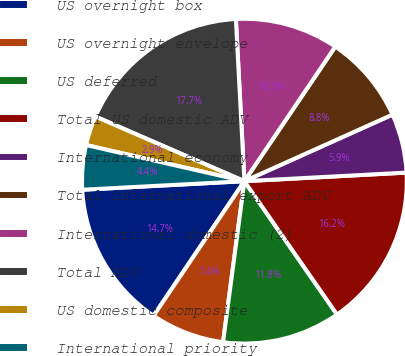<chart> <loc_0><loc_0><loc_500><loc_500><pie_chart><fcel>US overnight box<fcel>US overnight envelope<fcel>US deferred<fcel>Total US domestic ADV<fcel>International economy<fcel>Total international export ADV<fcel>International domestic (2)<fcel>Total ADV<fcel>US domestic composite<fcel>International priority<nl><fcel>14.71%<fcel>7.35%<fcel>11.76%<fcel>16.18%<fcel>5.88%<fcel>8.82%<fcel>10.29%<fcel>17.65%<fcel>2.94%<fcel>4.41%<nl></chart> 